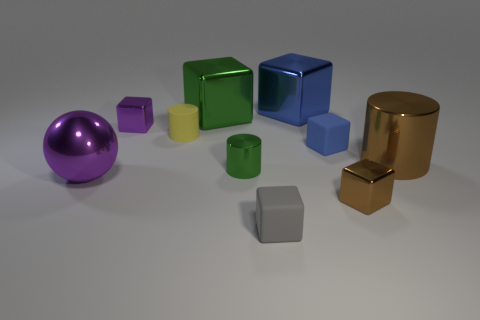Are there fewer matte cubes in front of the green metal cylinder than cubes on the right side of the green cube?
Offer a terse response. Yes. What shape is the big green thing that is made of the same material as the small purple thing?
Make the answer very short. Cube. Is there any other thing that has the same color as the tiny matte cylinder?
Keep it short and to the point. No. What is the color of the matte cube that is in front of the large shiny thing on the left side of the large green metal thing?
Your answer should be compact. Gray. There is a small cylinder behind the brown metal object behind the metallic object that is to the left of the purple block; what is its material?
Your answer should be very brief. Rubber. What number of purple metal spheres are the same size as the green shiny cylinder?
Give a very brief answer. 0. There is a small cube that is both behind the ball and on the right side of the green block; what is its material?
Your response must be concise. Rubber. There is a large brown metal cylinder; what number of green metal blocks are to the right of it?
Your response must be concise. 0. Do the gray thing and the tiny rubber thing that is to the right of the gray matte object have the same shape?
Give a very brief answer. Yes. Are there any other matte objects that have the same shape as the small gray thing?
Offer a very short reply. Yes. 